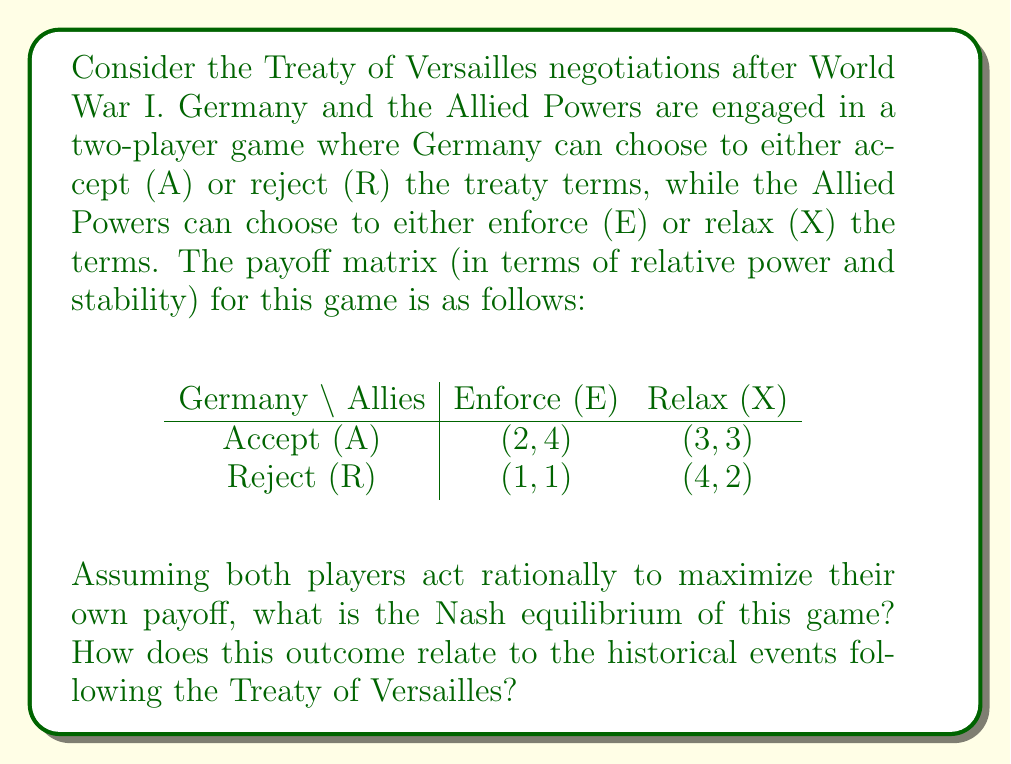Could you help me with this problem? To solve this problem, we need to analyze the game using the concept of Nash equilibrium from game theory. A Nash equilibrium is a set of strategies, one for each player, such that no player can unilaterally change their strategy to increase their payoff.

Let's examine each player's best responses:

1. Germany's perspective:
   - If Allies choose E: A (2) > R (1)
   - If Allies choose X: R (4) > A (3)

2. Allies' perspective:
   - If Germany chooses A: E (4) > X (3)
   - If Germany chooses R: X (2) > E (1)

To find the Nash equilibrium, we look for a strategy combination where both players are playing their best response to the other's strategy.

In this case, there is no pure strategy Nash equilibrium because:
- (A, E) is not stable as Germany would switch to R
- (A, X) is not stable as Allies would switch to E
- (R, E) is not stable as Germany would switch to A
- (R, X) is not stable as Allies would switch to E

Therefore, we need to consider a mixed strategy Nash equilibrium.

Let $p$ be the probability that Germany chooses A, and $q$ be the probability that Allies choose E.

For Germany to be indifferent between A and R:
$$ 2q + 3(1-q) = q + 4(1-q) $$
$$ 2q + 3 - 3q = q + 4 - 4q $$
$$ -q + 3 = -3q + 4 $$
$$ 2q = 1 $$
$$ q = \frac{1}{2} $$

For Allies to be indifferent between E and X:
$$ 4p + (1-p) = 3p + 2(1-p) $$
$$ 4p + 1 - p = 3p + 2 - 2p $$
$$ 3p + 1 = p + 2 $$
$$ 2p = 1 $$
$$ p = \frac{1}{2} $$

Therefore, the mixed strategy Nash equilibrium is $(p, q) = (\frac{1}{2}, \frac{1}{2})$, meaning both players choose each of their strategies with equal probability.

This outcome reflects the historical instability following the Treaty of Versailles. Germany's mixed strategy between accepting and rejecting the terms mirrors the fluctuating policies of the Weimar Republic, while the Allies' inconsistent enforcement of the treaty terms is represented by their mixed strategy.
Answer: The Nash equilibrium is a mixed strategy where both Germany and the Allied Powers choose each of their strategies with probability $\frac{1}{2}$. This reflects the historical instability and inconsistent policies following the Treaty of Versailles. 